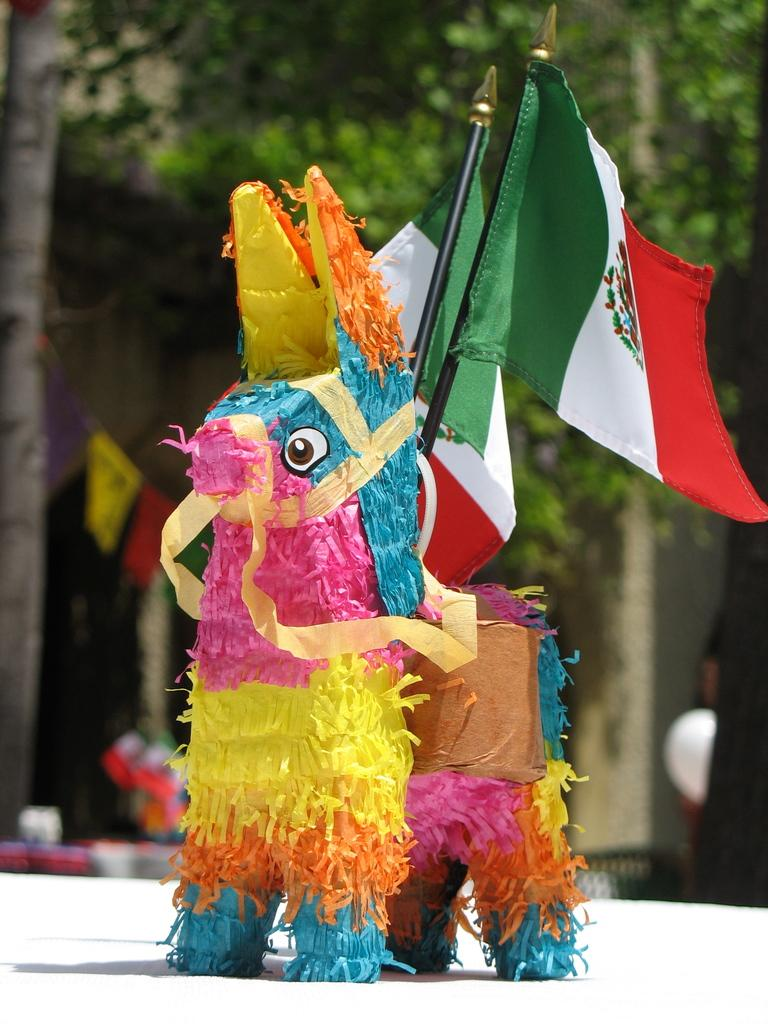What is the main subject of the image? There is a colorful decorative horse in the image. Where is the horse located in the image? The horse is in the front of the image. What is associated with the horse in the image? There are flags associated with the horse. How would you describe the background of the image? The background of the image is blurred. What type of vegetation can be seen in the background? Trees are visible in the background of the image. What type of leather is used to make the bait for the horse in the image? There is no bait or leather present in the image, as it features a decorative horse with flags. 